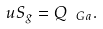<formula> <loc_0><loc_0><loc_500><loc_500>u S _ { g } = Q _ { \ G a } .</formula> 